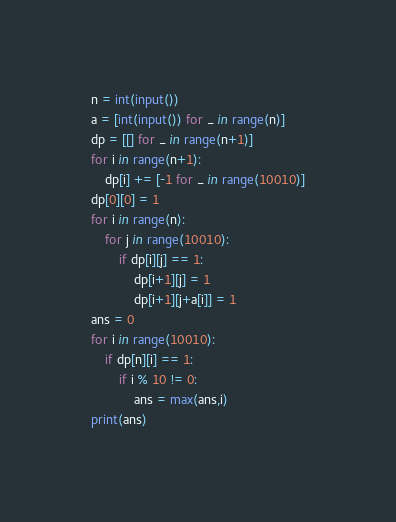<code> <loc_0><loc_0><loc_500><loc_500><_Python_>n = int(input())
a = [int(input()) for _ in range(n)]
dp = [[] for _ in range(n+1)]
for i in range(n+1):
    dp[i] += [-1 for _ in range(10010)]
dp[0][0] = 1
for i in range(n):
    for j in range(10010):
        if dp[i][j] == 1:
            dp[i+1][j] = 1
            dp[i+1][j+a[i]] = 1
ans = 0
for i in range(10010):
    if dp[n][i] == 1:
        if i % 10 != 0:
            ans = max(ans,i)
print(ans)</code> 